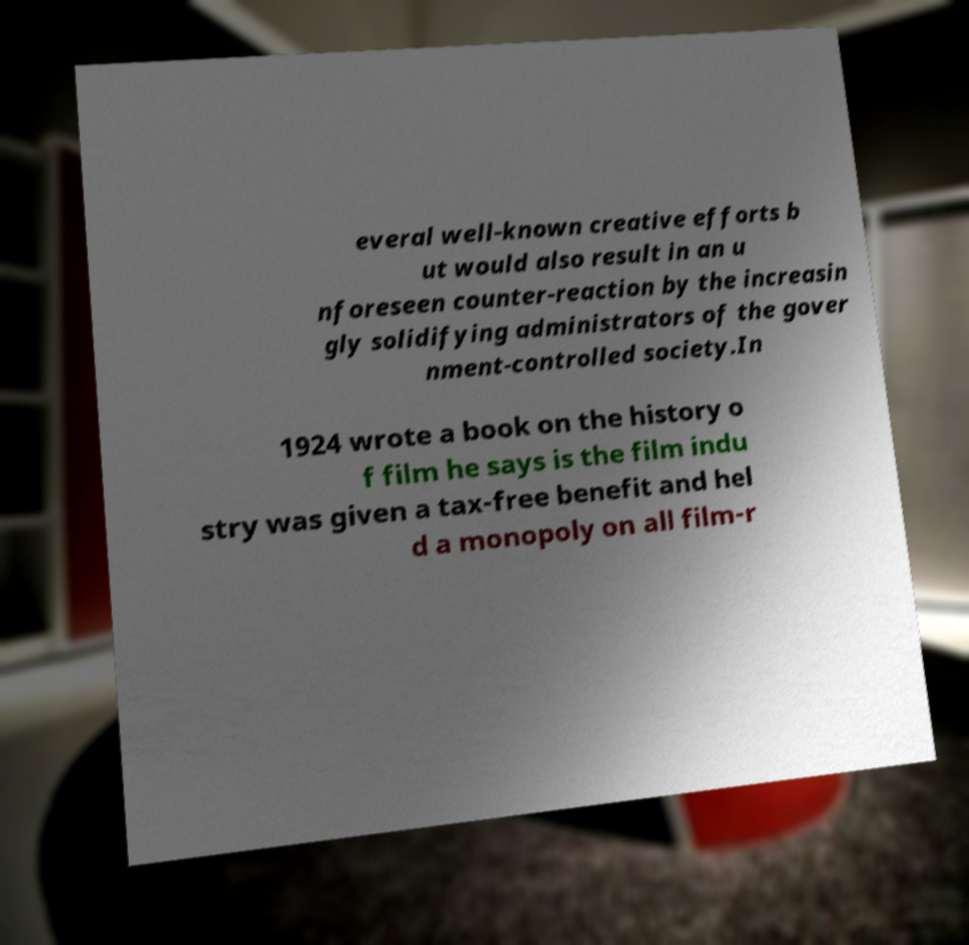For documentation purposes, I need the text within this image transcribed. Could you provide that? everal well-known creative efforts b ut would also result in an u nforeseen counter-reaction by the increasin gly solidifying administrators of the gover nment-controlled society.In 1924 wrote a book on the history o f film he says is the film indu stry was given a tax-free benefit and hel d a monopoly on all film-r 